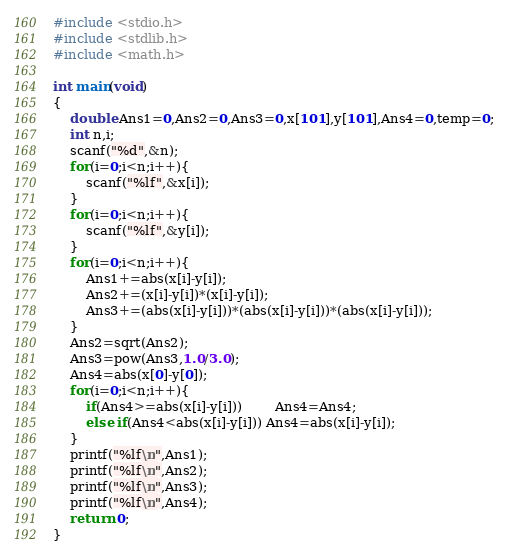<code> <loc_0><loc_0><loc_500><loc_500><_C_>#include <stdio.h>
#include <stdlib.h>
#include <math.h>

int main(void)
{
	double Ans1=0,Ans2=0,Ans3=0,x[101],y[101],Ans4=0,temp=0;
	int n,i;
	scanf("%d",&n);
	for(i=0;i<n;i++){
		scanf("%lf",&x[i]);
	}
	for(i=0;i<n;i++){
		scanf("%lf",&y[i]);
	}
	for(i=0;i<n;i++){
		Ans1+=abs(x[i]-y[i]);
		Ans2+=(x[i]-y[i])*(x[i]-y[i]);
		Ans3+=(abs(x[i]-y[i]))*(abs(x[i]-y[i]))*(abs(x[i]-y[i]));
	}
	Ans2=sqrt(Ans2);
	Ans3=pow(Ans3,1.0/3.0);
	Ans4=abs(x[0]-y[0]);
	for(i=0;i<n;i++){
		if(Ans4>=abs(x[i]-y[i]))		Ans4=Ans4;
		else if(Ans4<abs(x[i]-y[i])) Ans4=abs(x[i]-y[i]);
	}
	printf("%lf\n",Ans1);
	printf("%lf\n",Ans2);
	printf("%lf\n",Ans3);
	printf("%lf\n",Ans4);
	return 0;
}</code> 